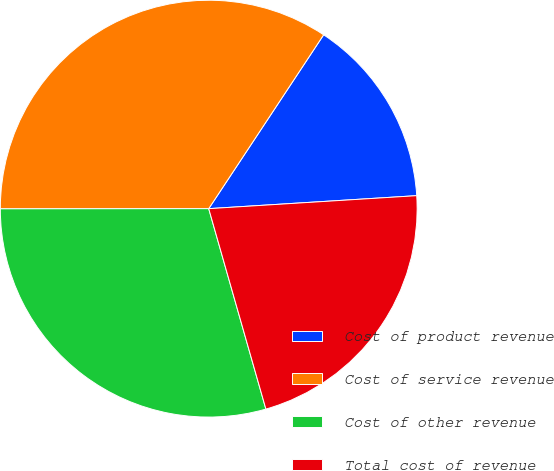Convert chart to OTSL. <chart><loc_0><loc_0><loc_500><loc_500><pie_chart><fcel>Cost of product revenue<fcel>Cost of service revenue<fcel>Cost of other revenue<fcel>Total cost of revenue<nl><fcel>14.71%<fcel>34.31%<fcel>29.41%<fcel>21.57%<nl></chart> 